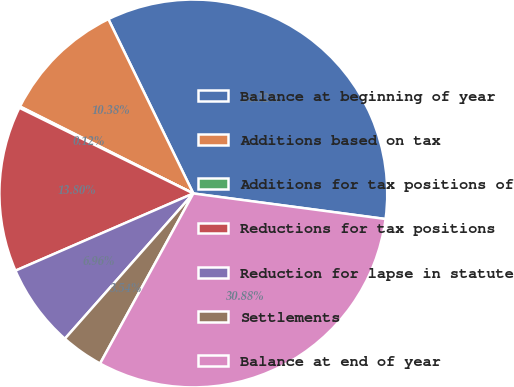Convert chart. <chart><loc_0><loc_0><loc_500><loc_500><pie_chart><fcel>Balance at beginning of year<fcel>Additions based on tax<fcel>Additions for tax positions of<fcel>Reductions for tax positions<fcel>Reduction for lapse in statute<fcel>Settlements<fcel>Balance at end of year<nl><fcel>34.32%<fcel>10.38%<fcel>0.12%<fcel>13.8%<fcel>6.96%<fcel>3.54%<fcel>30.88%<nl></chart> 